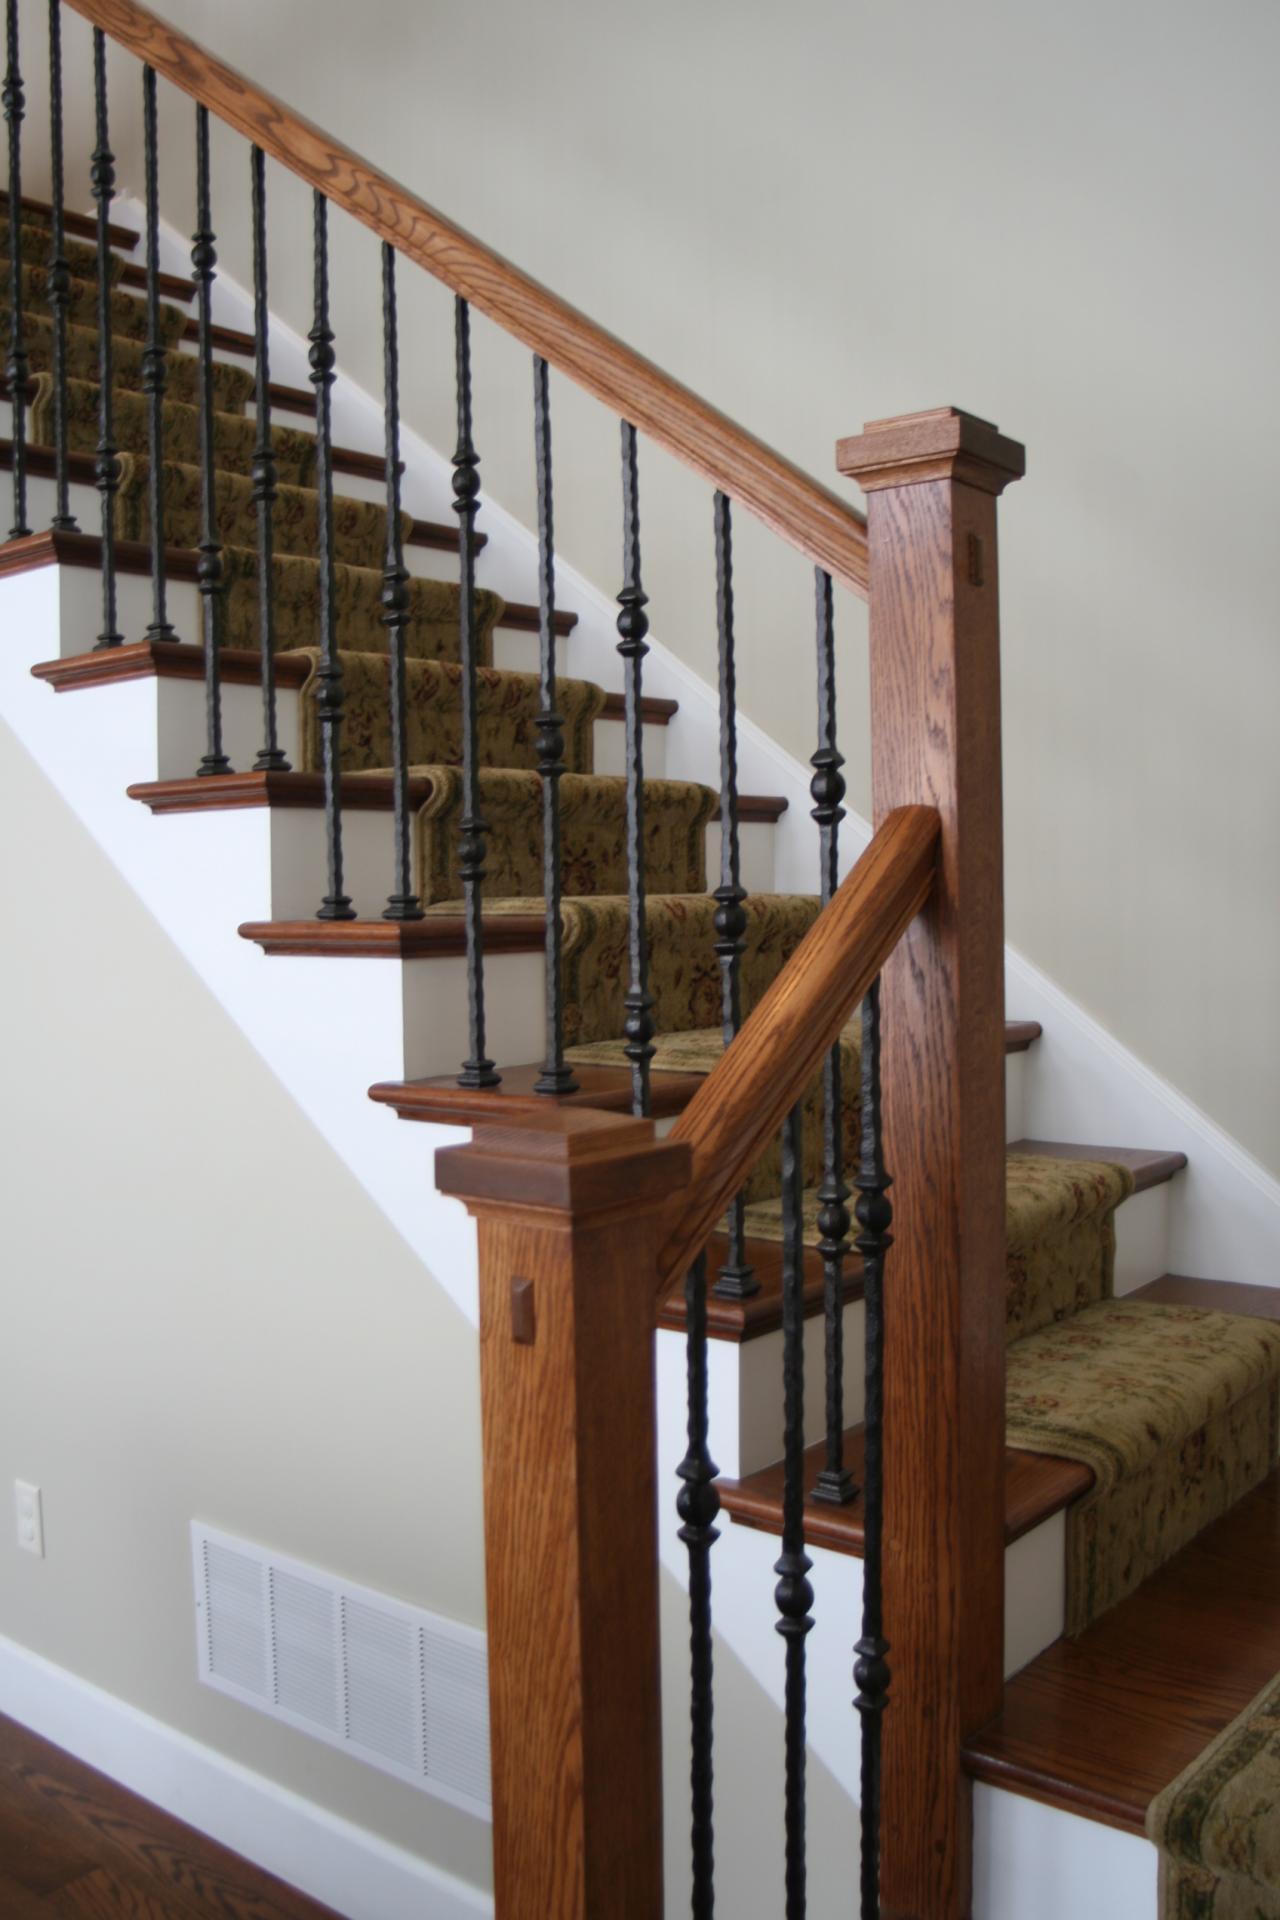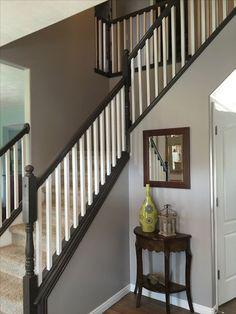The first image is the image on the left, the second image is the image on the right. Evaluate the accuracy of this statement regarding the images: "An image shows an ascending non-curved staircase with beige carpeted steps, dark handrails with a ball-topped corner post, and white vertical bars.". Is it true? Answer yes or no. Yes. 